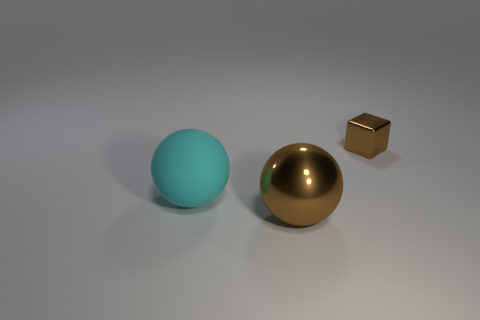Add 3 large metallic objects. How many objects exist? 6 Subtract all balls. How many objects are left? 1 Subtract all large rubber spheres. Subtract all cyan objects. How many objects are left? 1 Add 3 big rubber things. How many big rubber things are left? 4 Add 2 big red metallic objects. How many big red metallic objects exist? 2 Subtract 0 gray spheres. How many objects are left? 3 